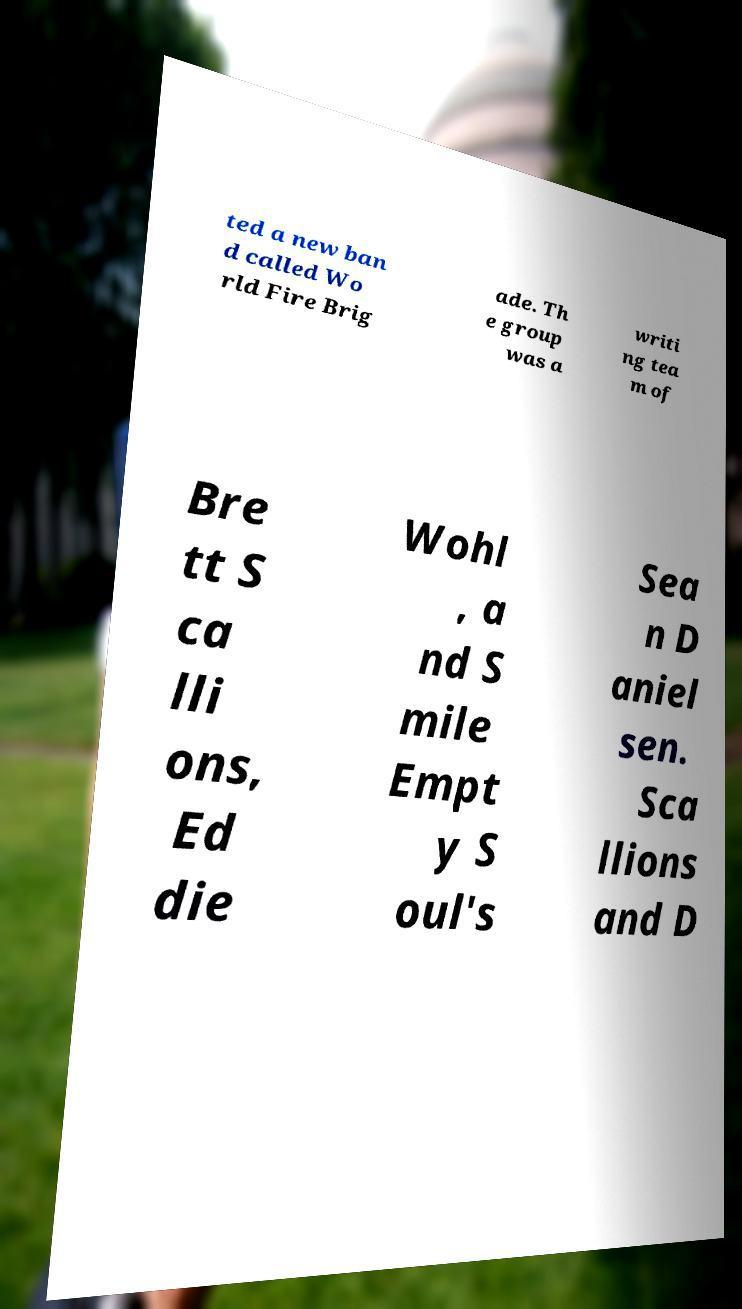Please read and relay the text visible in this image. What does it say? ted a new ban d called Wo rld Fire Brig ade. Th e group was a writi ng tea m of Bre tt S ca lli ons, Ed die Wohl , a nd S mile Empt y S oul's Sea n D aniel sen. Sca llions and D 